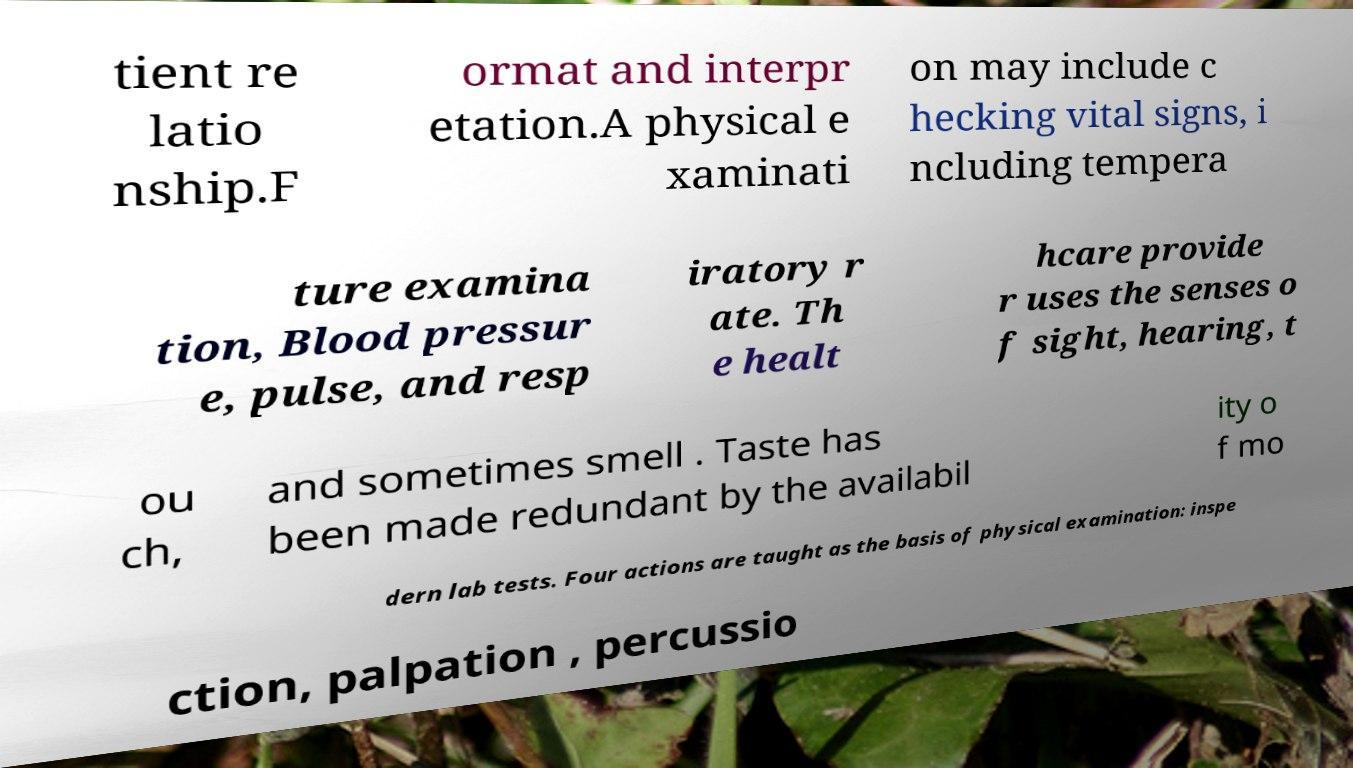Could you extract and type out the text from this image? tient re latio nship.F ormat and interpr etation.A physical e xaminati on may include c hecking vital signs, i ncluding tempera ture examina tion, Blood pressur e, pulse, and resp iratory r ate. Th e healt hcare provide r uses the senses o f sight, hearing, t ou ch, and sometimes smell . Taste has been made redundant by the availabil ity o f mo dern lab tests. Four actions are taught as the basis of physical examination: inspe ction, palpation , percussio 